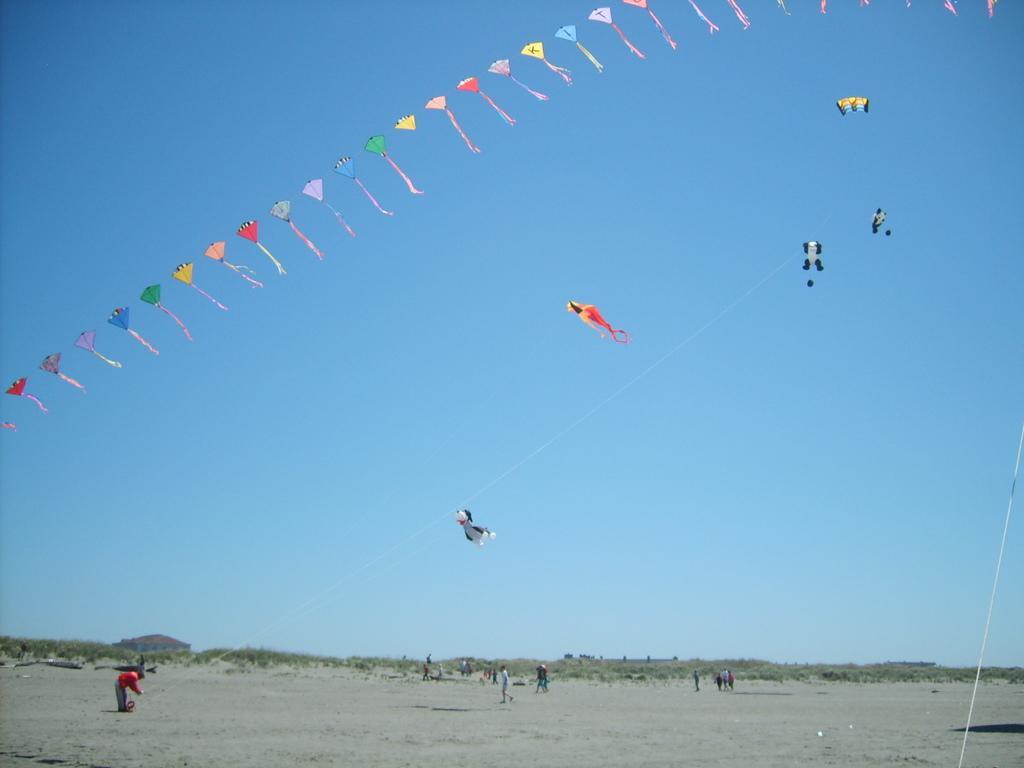In one or two sentences, can you explain what this image depicts? In this image at the bottom there are some people who are standing and they are flying kites, and some of them are walking. And on the top of the image there are some kites flying, in the background there are some trees and houses. At the bottom there is sand. 